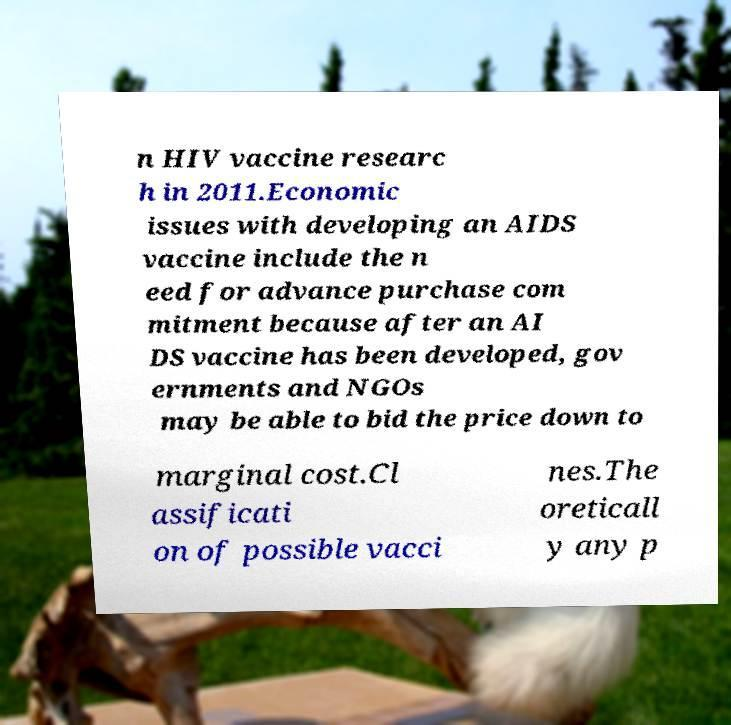There's text embedded in this image that I need extracted. Can you transcribe it verbatim? n HIV vaccine researc h in 2011.Economic issues with developing an AIDS vaccine include the n eed for advance purchase com mitment because after an AI DS vaccine has been developed, gov ernments and NGOs may be able to bid the price down to marginal cost.Cl assificati on of possible vacci nes.The oreticall y any p 